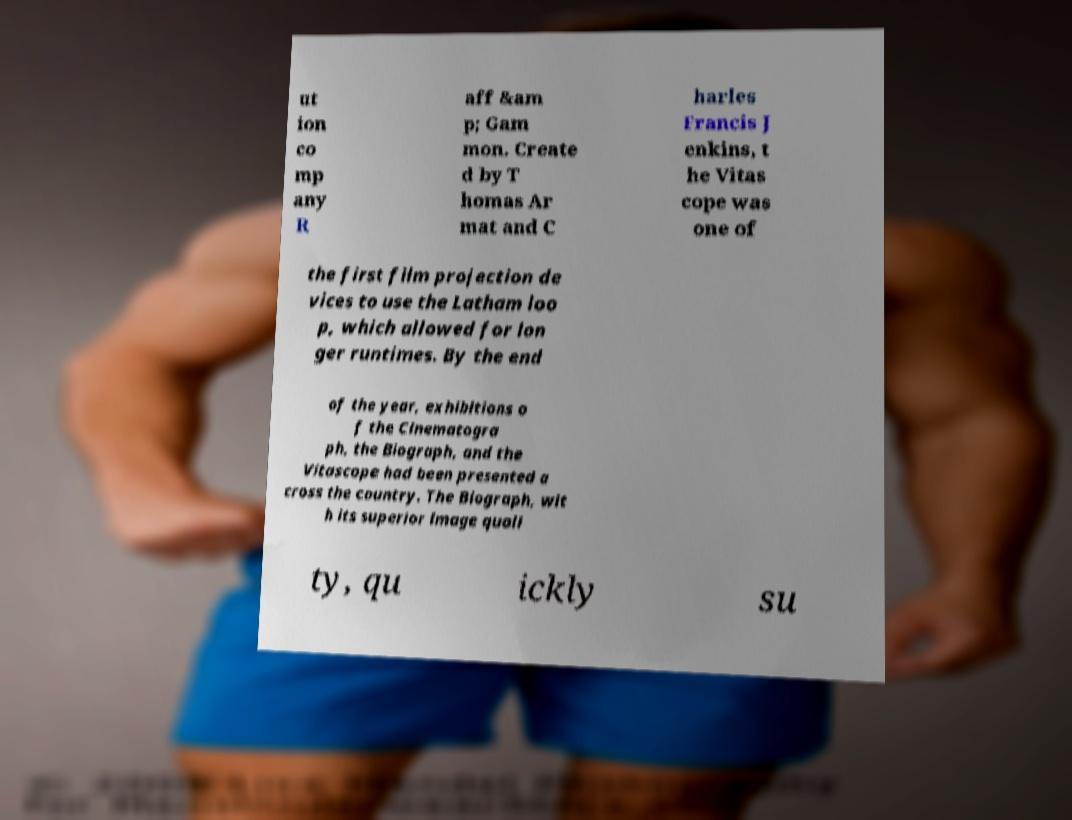Please identify and transcribe the text found in this image. ut ion co mp any R aff &am p; Gam mon. Create d by T homas Ar mat and C harles Francis J enkins, t he Vitas cope was one of the first film projection de vices to use the Latham loo p, which allowed for lon ger runtimes. By the end of the year, exhibitions o f the Cinematogra ph, the Biograph, and the Vitascope had been presented a cross the country. The Biograph, wit h its superior image quali ty, qu ickly su 